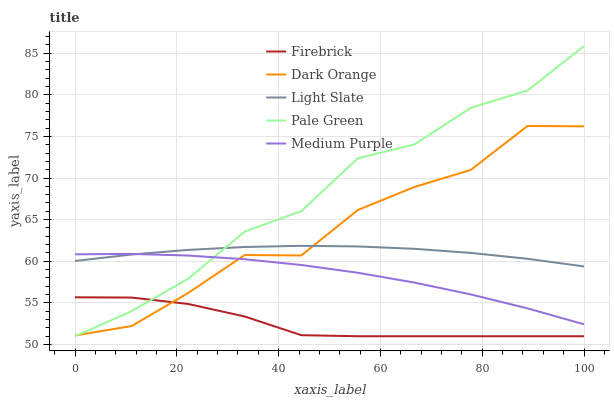Does Dark Orange have the minimum area under the curve?
Answer yes or no. No. Does Dark Orange have the maximum area under the curve?
Answer yes or no. No. Is Firebrick the smoothest?
Answer yes or no. No. Is Firebrick the roughest?
Answer yes or no. No. Does Dark Orange have the lowest value?
Answer yes or no. No. Does Dark Orange have the highest value?
Answer yes or no. No. Is Firebrick less than Light Slate?
Answer yes or no. Yes. Is Medium Purple greater than Firebrick?
Answer yes or no. Yes. Does Firebrick intersect Light Slate?
Answer yes or no. No. 